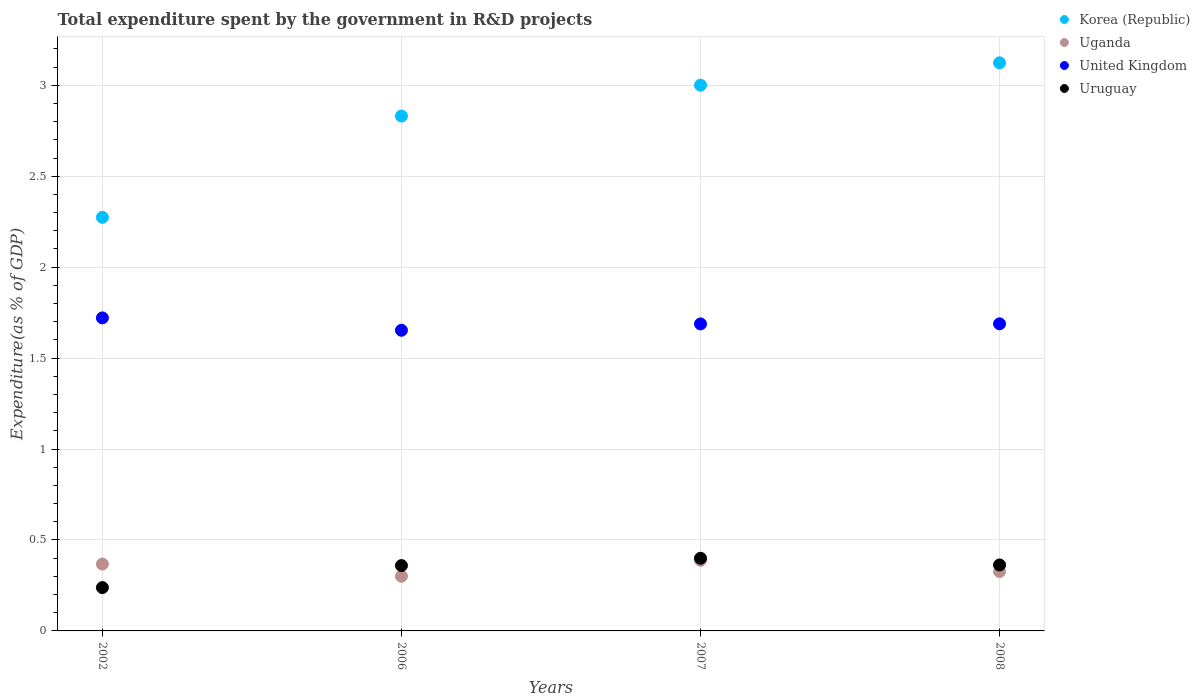What is the total expenditure spent by the government in R&D projects in Korea (Republic) in 2006?
Your answer should be very brief. 2.83. Across all years, what is the maximum total expenditure spent by the government in R&D projects in Uruguay?
Give a very brief answer. 0.4. Across all years, what is the minimum total expenditure spent by the government in R&D projects in United Kingdom?
Your answer should be compact. 1.65. In which year was the total expenditure spent by the government in R&D projects in Uganda maximum?
Provide a short and direct response. 2007. What is the total total expenditure spent by the government in R&D projects in Uganda in the graph?
Ensure brevity in your answer.  1.38. What is the difference between the total expenditure spent by the government in R&D projects in Uganda in 2006 and that in 2007?
Keep it short and to the point. -0.09. What is the difference between the total expenditure spent by the government in R&D projects in United Kingdom in 2006 and the total expenditure spent by the government in R&D projects in Korea (Republic) in 2007?
Keep it short and to the point. -1.35. What is the average total expenditure spent by the government in R&D projects in Uruguay per year?
Keep it short and to the point. 0.34. In the year 2002, what is the difference between the total expenditure spent by the government in R&D projects in Korea (Republic) and total expenditure spent by the government in R&D projects in Uganda?
Provide a short and direct response. 1.91. In how many years, is the total expenditure spent by the government in R&D projects in Korea (Republic) greater than 2.5 %?
Your answer should be very brief. 3. What is the ratio of the total expenditure spent by the government in R&D projects in Uganda in 2002 to that in 2006?
Provide a short and direct response. 1.22. Is the total expenditure spent by the government in R&D projects in United Kingdom in 2006 less than that in 2008?
Make the answer very short. Yes. Is the difference between the total expenditure spent by the government in R&D projects in Korea (Republic) in 2002 and 2008 greater than the difference between the total expenditure spent by the government in R&D projects in Uganda in 2002 and 2008?
Ensure brevity in your answer.  No. What is the difference between the highest and the second highest total expenditure spent by the government in R&D projects in Korea (Republic)?
Offer a terse response. 0.12. What is the difference between the highest and the lowest total expenditure spent by the government in R&D projects in Uruguay?
Provide a succinct answer. 0.16. In how many years, is the total expenditure spent by the government in R&D projects in Uganda greater than the average total expenditure spent by the government in R&D projects in Uganda taken over all years?
Your answer should be compact. 2. Is it the case that in every year, the sum of the total expenditure spent by the government in R&D projects in Uruguay and total expenditure spent by the government in R&D projects in Korea (Republic)  is greater than the sum of total expenditure spent by the government in R&D projects in Uganda and total expenditure spent by the government in R&D projects in United Kingdom?
Make the answer very short. Yes. Is it the case that in every year, the sum of the total expenditure spent by the government in R&D projects in Uganda and total expenditure spent by the government in R&D projects in Uruguay  is greater than the total expenditure spent by the government in R&D projects in Korea (Republic)?
Your response must be concise. No. Does the graph contain any zero values?
Ensure brevity in your answer.  No. Does the graph contain grids?
Your answer should be very brief. Yes. Where does the legend appear in the graph?
Ensure brevity in your answer.  Top right. How many legend labels are there?
Your answer should be very brief. 4. How are the legend labels stacked?
Provide a short and direct response. Vertical. What is the title of the graph?
Your response must be concise. Total expenditure spent by the government in R&D projects. What is the label or title of the X-axis?
Provide a succinct answer. Years. What is the label or title of the Y-axis?
Provide a short and direct response. Expenditure(as % of GDP). What is the Expenditure(as % of GDP) of Korea (Republic) in 2002?
Give a very brief answer. 2.27. What is the Expenditure(as % of GDP) in Uganda in 2002?
Keep it short and to the point. 0.37. What is the Expenditure(as % of GDP) in United Kingdom in 2002?
Keep it short and to the point. 1.72. What is the Expenditure(as % of GDP) in Uruguay in 2002?
Your answer should be very brief. 0.24. What is the Expenditure(as % of GDP) in Korea (Republic) in 2006?
Keep it short and to the point. 2.83. What is the Expenditure(as % of GDP) of Uganda in 2006?
Keep it short and to the point. 0.3. What is the Expenditure(as % of GDP) of United Kingdom in 2006?
Offer a very short reply. 1.65. What is the Expenditure(as % of GDP) in Uruguay in 2006?
Offer a very short reply. 0.36. What is the Expenditure(as % of GDP) in Korea (Republic) in 2007?
Your answer should be compact. 3. What is the Expenditure(as % of GDP) of Uganda in 2007?
Your response must be concise. 0.39. What is the Expenditure(as % of GDP) in United Kingdom in 2007?
Offer a terse response. 1.69. What is the Expenditure(as % of GDP) in Uruguay in 2007?
Provide a succinct answer. 0.4. What is the Expenditure(as % of GDP) in Korea (Republic) in 2008?
Keep it short and to the point. 3.12. What is the Expenditure(as % of GDP) of Uganda in 2008?
Keep it short and to the point. 0.33. What is the Expenditure(as % of GDP) in United Kingdom in 2008?
Your answer should be compact. 1.69. What is the Expenditure(as % of GDP) in Uruguay in 2008?
Your answer should be compact. 0.36. Across all years, what is the maximum Expenditure(as % of GDP) of Korea (Republic)?
Keep it short and to the point. 3.12. Across all years, what is the maximum Expenditure(as % of GDP) in Uganda?
Provide a succinct answer. 0.39. Across all years, what is the maximum Expenditure(as % of GDP) of United Kingdom?
Your response must be concise. 1.72. Across all years, what is the maximum Expenditure(as % of GDP) in Uruguay?
Your answer should be very brief. 0.4. Across all years, what is the minimum Expenditure(as % of GDP) of Korea (Republic)?
Give a very brief answer. 2.27. Across all years, what is the minimum Expenditure(as % of GDP) of Uganda?
Offer a terse response. 0.3. Across all years, what is the minimum Expenditure(as % of GDP) of United Kingdom?
Your response must be concise. 1.65. Across all years, what is the minimum Expenditure(as % of GDP) of Uruguay?
Your answer should be compact. 0.24. What is the total Expenditure(as % of GDP) of Korea (Republic) in the graph?
Make the answer very short. 11.23. What is the total Expenditure(as % of GDP) in Uganda in the graph?
Provide a short and direct response. 1.38. What is the total Expenditure(as % of GDP) of United Kingdom in the graph?
Ensure brevity in your answer.  6.75. What is the total Expenditure(as % of GDP) of Uruguay in the graph?
Provide a succinct answer. 1.36. What is the difference between the Expenditure(as % of GDP) of Korea (Republic) in 2002 and that in 2006?
Keep it short and to the point. -0.56. What is the difference between the Expenditure(as % of GDP) in Uganda in 2002 and that in 2006?
Ensure brevity in your answer.  0.07. What is the difference between the Expenditure(as % of GDP) of United Kingdom in 2002 and that in 2006?
Make the answer very short. 0.07. What is the difference between the Expenditure(as % of GDP) in Uruguay in 2002 and that in 2006?
Keep it short and to the point. -0.12. What is the difference between the Expenditure(as % of GDP) in Korea (Republic) in 2002 and that in 2007?
Make the answer very short. -0.73. What is the difference between the Expenditure(as % of GDP) of Uganda in 2002 and that in 2007?
Offer a terse response. -0.02. What is the difference between the Expenditure(as % of GDP) of United Kingdom in 2002 and that in 2007?
Make the answer very short. 0.03. What is the difference between the Expenditure(as % of GDP) of Uruguay in 2002 and that in 2007?
Keep it short and to the point. -0.16. What is the difference between the Expenditure(as % of GDP) of Korea (Republic) in 2002 and that in 2008?
Your answer should be compact. -0.85. What is the difference between the Expenditure(as % of GDP) in Uganda in 2002 and that in 2008?
Your answer should be compact. 0.04. What is the difference between the Expenditure(as % of GDP) in United Kingdom in 2002 and that in 2008?
Make the answer very short. 0.03. What is the difference between the Expenditure(as % of GDP) in Uruguay in 2002 and that in 2008?
Provide a short and direct response. -0.12. What is the difference between the Expenditure(as % of GDP) in Korea (Republic) in 2006 and that in 2007?
Offer a terse response. -0.17. What is the difference between the Expenditure(as % of GDP) of Uganda in 2006 and that in 2007?
Make the answer very short. -0.09. What is the difference between the Expenditure(as % of GDP) of United Kingdom in 2006 and that in 2007?
Provide a short and direct response. -0.03. What is the difference between the Expenditure(as % of GDP) of Uruguay in 2006 and that in 2007?
Make the answer very short. -0.04. What is the difference between the Expenditure(as % of GDP) of Korea (Republic) in 2006 and that in 2008?
Ensure brevity in your answer.  -0.29. What is the difference between the Expenditure(as % of GDP) in Uganda in 2006 and that in 2008?
Offer a very short reply. -0.03. What is the difference between the Expenditure(as % of GDP) in United Kingdom in 2006 and that in 2008?
Give a very brief answer. -0.04. What is the difference between the Expenditure(as % of GDP) of Uruguay in 2006 and that in 2008?
Your answer should be compact. -0. What is the difference between the Expenditure(as % of GDP) of Korea (Republic) in 2007 and that in 2008?
Offer a very short reply. -0.12. What is the difference between the Expenditure(as % of GDP) of Uganda in 2007 and that in 2008?
Give a very brief answer. 0.06. What is the difference between the Expenditure(as % of GDP) in United Kingdom in 2007 and that in 2008?
Keep it short and to the point. -0. What is the difference between the Expenditure(as % of GDP) of Uruguay in 2007 and that in 2008?
Your response must be concise. 0.04. What is the difference between the Expenditure(as % of GDP) in Korea (Republic) in 2002 and the Expenditure(as % of GDP) in Uganda in 2006?
Your answer should be very brief. 1.97. What is the difference between the Expenditure(as % of GDP) of Korea (Republic) in 2002 and the Expenditure(as % of GDP) of United Kingdom in 2006?
Offer a terse response. 0.62. What is the difference between the Expenditure(as % of GDP) of Korea (Republic) in 2002 and the Expenditure(as % of GDP) of Uruguay in 2006?
Your response must be concise. 1.91. What is the difference between the Expenditure(as % of GDP) in Uganda in 2002 and the Expenditure(as % of GDP) in United Kingdom in 2006?
Ensure brevity in your answer.  -1.29. What is the difference between the Expenditure(as % of GDP) of Uganda in 2002 and the Expenditure(as % of GDP) of Uruguay in 2006?
Provide a short and direct response. 0.01. What is the difference between the Expenditure(as % of GDP) of United Kingdom in 2002 and the Expenditure(as % of GDP) of Uruguay in 2006?
Offer a terse response. 1.36. What is the difference between the Expenditure(as % of GDP) of Korea (Republic) in 2002 and the Expenditure(as % of GDP) of Uganda in 2007?
Provide a succinct answer. 1.89. What is the difference between the Expenditure(as % of GDP) in Korea (Republic) in 2002 and the Expenditure(as % of GDP) in United Kingdom in 2007?
Offer a very short reply. 0.59. What is the difference between the Expenditure(as % of GDP) in Korea (Republic) in 2002 and the Expenditure(as % of GDP) in Uruguay in 2007?
Offer a terse response. 1.87. What is the difference between the Expenditure(as % of GDP) in Uganda in 2002 and the Expenditure(as % of GDP) in United Kingdom in 2007?
Provide a succinct answer. -1.32. What is the difference between the Expenditure(as % of GDP) of Uganda in 2002 and the Expenditure(as % of GDP) of Uruguay in 2007?
Offer a very short reply. -0.03. What is the difference between the Expenditure(as % of GDP) in United Kingdom in 2002 and the Expenditure(as % of GDP) in Uruguay in 2007?
Provide a succinct answer. 1.32. What is the difference between the Expenditure(as % of GDP) in Korea (Republic) in 2002 and the Expenditure(as % of GDP) in Uganda in 2008?
Your answer should be very brief. 1.95. What is the difference between the Expenditure(as % of GDP) of Korea (Republic) in 2002 and the Expenditure(as % of GDP) of United Kingdom in 2008?
Make the answer very short. 0.59. What is the difference between the Expenditure(as % of GDP) of Korea (Republic) in 2002 and the Expenditure(as % of GDP) of Uruguay in 2008?
Give a very brief answer. 1.91. What is the difference between the Expenditure(as % of GDP) of Uganda in 2002 and the Expenditure(as % of GDP) of United Kingdom in 2008?
Your response must be concise. -1.32. What is the difference between the Expenditure(as % of GDP) in Uganda in 2002 and the Expenditure(as % of GDP) in Uruguay in 2008?
Provide a succinct answer. 0. What is the difference between the Expenditure(as % of GDP) of United Kingdom in 2002 and the Expenditure(as % of GDP) of Uruguay in 2008?
Offer a terse response. 1.36. What is the difference between the Expenditure(as % of GDP) in Korea (Republic) in 2006 and the Expenditure(as % of GDP) in Uganda in 2007?
Your answer should be compact. 2.44. What is the difference between the Expenditure(as % of GDP) in Korea (Republic) in 2006 and the Expenditure(as % of GDP) in United Kingdom in 2007?
Your response must be concise. 1.14. What is the difference between the Expenditure(as % of GDP) of Korea (Republic) in 2006 and the Expenditure(as % of GDP) of Uruguay in 2007?
Your response must be concise. 2.43. What is the difference between the Expenditure(as % of GDP) in Uganda in 2006 and the Expenditure(as % of GDP) in United Kingdom in 2007?
Provide a short and direct response. -1.39. What is the difference between the Expenditure(as % of GDP) in Uganda in 2006 and the Expenditure(as % of GDP) in Uruguay in 2007?
Keep it short and to the point. -0.1. What is the difference between the Expenditure(as % of GDP) of United Kingdom in 2006 and the Expenditure(as % of GDP) of Uruguay in 2007?
Your response must be concise. 1.25. What is the difference between the Expenditure(as % of GDP) in Korea (Republic) in 2006 and the Expenditure(as % of GDP) in Uganda in 2008?
Ensure brevity in your answer.  2.5. What is the difference between the Expenditure(as % of GDP) in Korea (Republic) in 2006 and the Expenditure(as % of GDP) in United Kingdom in 2008?
Ensure brevity in your answer.  1.14. What is the difference between the Expenditure(as % of GDP) in Korea (Republic) in 2006 and the Expenditure(as % of GDP) in Uruguay in 2008?
Make the answer very short. 2.47. What is the difference between the Expenditure(as % of GDP) of Uganda in 2006 and the Expenditure(as % of GDP) of United Kingdom in 2008?
Provide a short and direct response. -1.39. What is the difference between the Expenditure(as % of GDP) of Uganda in 2006 and the Expenditure(as % of GDP) of Uruguay in 2008?
Offer a terse response. -0.06. What is the difference between the Expenditure(as % of GDP) in United Kingdom in 2006 and the Expenditure(as % of GDP) in Uruguay in 2008?
Provide a short and direct response. 1.29. What is the difference between the Expenditure(as % of GDP) of Korea (Republic) in 2007 and the Expenditure(as % of GDP) of Uganda in 2008?
Provide a short and direct response. 2.67. What is the difference between the Expenditure(as % of GDP) in Korea (Republic) in 2007 and the Expenditure(as % of GDP) in United Kingdom in 2008?
Make the answer very short. 1.31. What is the difference between the Expenditure(as % of GDP) of Korea (Republic) in 2007 and the Expenditure(as % of GDP) of Uruguay in 2008?
Your answer should be very brief. 2.64. What is the difference between the Expenditure(as % of GDP) of Uganda in 2007 and the Expenditure(as % of GDP) of United Kingdom in 2008?
Provide a short and direct response. -1.3. What is the difference between the Expenditure(as % of GDP) of Uganda in 2007 and the Expenditure(as % of GDP) of Uruguay in 2008?
Your answer should be compact. 0.03. What is the difference between the Expenditure(as % of GDP) of United Kingdom in 2007 and the Expenditure(as % of GDP) of Uruguay in 2008?
Your response must be concise. 1.33. What is the average Expenditure(as % of GDP) of Korea (Republic) per year?
Your answer should be compact. 2.81. What is the average Expenditure(as % of GDP) of Uganda per year?
Make the answer very short. 0.35. What is the average Expenditure(as % of GDP) in United Kingdom per year?
Provide a succinct answer. 1.69. What is the average Expenditure(as % of GDP) of Uruguay per year?
Your answer should be compact. 0.34. In the year 2002, what is the difference between the Expenditure(as % of GDP) in Korea (Republic) and Expenditure(as % of GDP) in Uganda?
Your answer should be compact. 1.91. In the year 2002, what is the difference between the Expenditure(as % of GDP) in Korea (Republic) and Expenditure(as % of GDP) in United Kingdom?
Make the answer very short. 0.55. In the year 2002, what is the difference between the Expenditure(as % of GDP) in Korea (Republic) and Expenditure(as % of GDP) in Uruguay?
Keep it short and to the point. 2.04. In the year 2002, what is the difference between the Expenditure(as % of GDP) in Uganda and Expenditure(as % of GDP) in United Kingdom?
Provide a short and direct response. -1.35. In the year 2002, what is the difference between the Expenditure(as % of GDP) of Uganda and Expenditure(as % of GDP) of Uruguay?
Provide a succinct answer. 0.13. In the year 2002, what is the difference between the Expenditure(as % of GDP) in United Kingdom and Expenditure(as % of GDP) in Uruguay?
Your answer should be compact. 1.48. In the year 2006, what is the difference between the Expenditure(as % of GDP) of Korea (Republic) and Expenditure(as % of GDP) of Uganda?
Offer a very short reply. 2.53. In the year 2006, what is the difference between the Expenditure(as % of GDP) in Korea (Republic) and Expenditure(as % of GDP) in United Kingdom?
Make the answer very short. 1.18. In the year 2006, what is the difference between the Expenditure(as % of GDP) in Korea (Republic) and Expenditure(as % of GDP) in Uruguay?
Ensure brevity in your answer.  2.47. In the year 2006, what is the difference between the Expenditure(as % of GDP) in Uganda and Expenditure(as % of GDP) in United Kingdom?
Provide a succinct answer. -1.35. In the year 2006, what is the difference between the Expenditure(as % of GDP) in Uganda and Expenditure(as % of GDP) in Uruguay?
Your answer should be compact. -0.06. In the year 2006, what is the difference between the Expenditure(as % of GDP) in United Kingdom and Expenditure(as % of GDP) in Uruguay?
Your answer should be compact. 1.29. In the year 2007, what is the difference between the Expenditure(as % of GDP) in Korea (Republic) and Expenditure(as % of GDP) in Uganda?
Keep it short and to the point. 2.61. In the year 2007, what is the difference between the Expenditure(as % of GDP) in Korea (Republic) and Expenditure(as % of GDP) in United Kingdom?
Provide a succinct answer. 1.31. In the year 2007, what is the difference between the Expenditure(as % of GDP) of Korea (Republic) and Expenditure(as % of GDP) of Uruguay?
Provide a short and direct response. 2.6. In the year 2007, what is the difference between the Expenditure(as % of GDP) in Uganda and Expenditure(as % of GDP) in United Kingdom?
Provide a short and direct response. -1.3. In the year 2007, what is the difference between the Expenditure(as % of GDP) in Uganda and Expenditure(as % of GDP) in Uruguay?
Make the answer very short. -0.01. In the year 2007, what is the difference between the Expenditure(as % of GDP) of United Kingdom and Expenditure(as % of GDP) of Uruguay?
Provide a short and direct response. 1.29. In the year 2008, what is the difference between the Expenditure(as % of GDP) of Korea (Republic) and Expenditure(as % of GDP) of Uganda?
Give a very brief answer. 2.8. In the year 2008, what is the difference between the Expenditure(as % of GDP) of Korea (Republic) and Expenditure(as % of GDP) of United Kingdom?
Offer a terse response. 1.44. In the year 2008, what is the difference between the Expenditure(as % of GDP) of Korea (Republic) and Expenditure(as % of GDP) of Uruguay?
Ensure brevity in your answer.  2.76. In the year 2008, what is the difference between the Expenditure(as % of GDP) in Uganda and Expenditure(as % of GDP) in United Kingdom?
Your answer should be compact. -1.36. In the year 2008, what is the difference between the Expenditure(as % of GDP) in Uganda and Expenditure(as % of GDP) in Uruguay?
Ensure brevity in your answer.  -0.04. In the year 2008, what is the difference between the Expenditure(as % of GDP) in United Kingdom and Expenditure(as % of GDP) in Uruguay?
Keep it short and to the point. 1.33. What is the ratio of the Expenditure(as % of GDP) of Korea (Republic) in 2002 to that in 2006?
Ensure brevity in your answer.  0.8. What is the ratio of the Expenditure(as % of GDP) of Uganda in 2002 to that in 2006?
Your answer should be compact. 1.22. What is the ratio of the Expenditure(as % of GDP) of United Kingdom in 2002 to that in 2006?
Offer a terse response. 1.04. What is the ratio of the Expenditure(as % of GDP) in Uruguay in 2002 to that in 2006?
Make the answer very short. 0.66. What is the ratio of the Expenditure(as % of GDP) in Korea (Republic) in 2002 to that in 2007?
Ensure brevity in your answer.  0.76. What is the ratio of the Expenditure(as % of GDP) of Uganda in 2002 to that in 2007?
Offer a very short reply. 0.95. What is the ratio of the Expenditure(as % of GDP) in United Kingdom in 2002 to that in 2007?
Provide a short and direct response. 1.02. What is the ratio of the Expenditure(as % of GDP) in Uruguay in 2002 to that in 2007?
Provide a short and direct response. 0.6. What is the ratio of the Expenditure(as % of GDP) in Korea (Republic) in 2002 to that in 2008?
Keep it short and to the point. 0.73. What is the ratio of the Expenditure(as % of GDP) in Uganda in 2002 to that in 2008?
Provide a succinct answer. 1.13. What is the ratio of the Expenditure(as % of GDP) in United Kingdom in 2002 to that in 2008?
Offer a very short reply. 1.02. What is the ratio of the Expenditure(as % of GDP) in Uruguay in 2002 to that in 2008?
Make the answer very short. 0.66. What is the ratio of the Expenditure(as % of GDP) in Korea (Republic) in 2006 to that in 2007?
Make the answer very short. 0.94. What is the ratio of the Expenditure(as % of GDP) in Uganda in 2006 to that in 2007?
Ensure brevity in your answer.  0.77. What is the ratio of the Expenditure(as % of GDP) in United Kingdom in 2006 to that in 2007?
Keep it short and to the point. 0.98. What is the ratio of the Expenditure(as % of GDP) in Uruguay in 2006 to that in 2007?
Offer a very short reply. 0.9. What is the ratio of the Expenditure(as % of GDP) in Korea (Republic) in 2006 to that in 2008?
Ensure brevity in your answer.  0.91. What is the ratio of the Expenditure(as % of GDP) in Uganda in 2006 to that in 2008?
Your response must be concise. 0.92. What is the ratio of the Expenditure(as % of GDP) in Uruguay in 2006 to that in 2008?
Make the answer very short. 0.99. What is the ratio of the Expenditure(as % of GDP) of Korea (Republic) in 2007 to that in 2008?
Your answer should be very brief. 0.96. What is the ratio of the Expenditure(as % of GDP) of Uganda in 2007 to that in 2008?
Offer a very short reply. 1.19. What is the ratio of the Expenditure(as % of GDP) of United Kingdom in 2007 to that in 2008?
Your answer should be compact. 1. What is the ratio of the Expenditure(as % of GDP) in Uruguay in 2007 to that in 2008?
Your answer should be compact. 1.1. What is the difference between the highest and the second highest Expenditure(as % of GDP) of Korea (Republic)?
Offer a very short reply. 0.12. What is the difference between the highest and the second highest Expenditure(as % of GDP) of Uganda?
Make the answer very short. 0.02. What is the difference between the highest and the second highest Expenditure(as % of GDP) in United Kingdom?
Provide a succinct answer. 0.03. What is the difference between the highest and the second highest Expenditure(as % of GDP) of Uruguay?
Provide a short and direct response. 0.04. What is the difference between the highest and the lowest Expenditure(as % of GDP) in Korea (Republic)?
Offer a terse response. 0.85. What is the difference between the highest and the lowest Expenditure(as % of GDP) of Uganda?
Give a very brief answer. 0.09. What is the difference between the highest and the lowest Expenditure(as % of GDP) in United Kingdom?
Offer a terse response. 0.07. What is the difference between the highest and the lowest Expenditure(as % of GDP) of Uruguay?
Give a very brief answer. 0.16. 